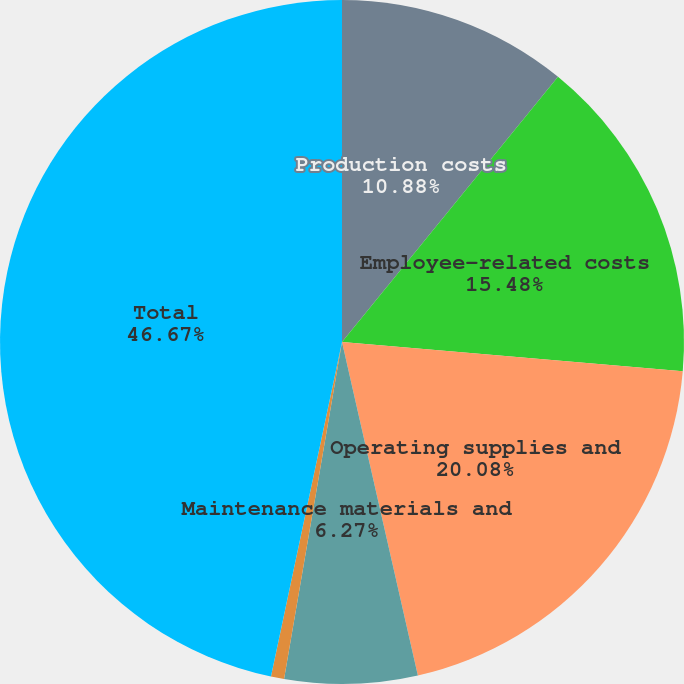Convert chart. <chart><loc_0><loc_0><loc_500><loc_500><pie_chart><fcel>Production costs<fcel>Employee-related costs<fcel>Operating supplies and<fcel>Maintenance materials and<fcel>Other<fcel>Total<nl><fcel>10.88%<fcel>15.48%<fcel>20.08%<fcel>6.27%<fcel>0.62%<fcel>46.67%<nl></chart> 